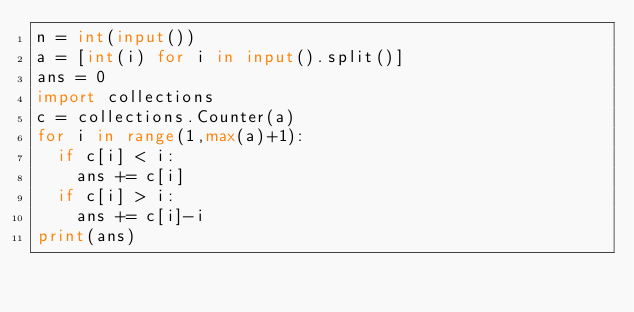Convert code to text. <code><loc_0><loc_0><loc_500><loc_500><_Python_>n = int(input())
a = [int(i) for i in input().split()]
ans = 0
import collections
c = collections.Counter(a)
for i in range(1,max(a)+1):
  if c[i] < i:
    ans += c[i]
  if c[i] > i:
    ans += c[i]-i
print(ans)</code> 